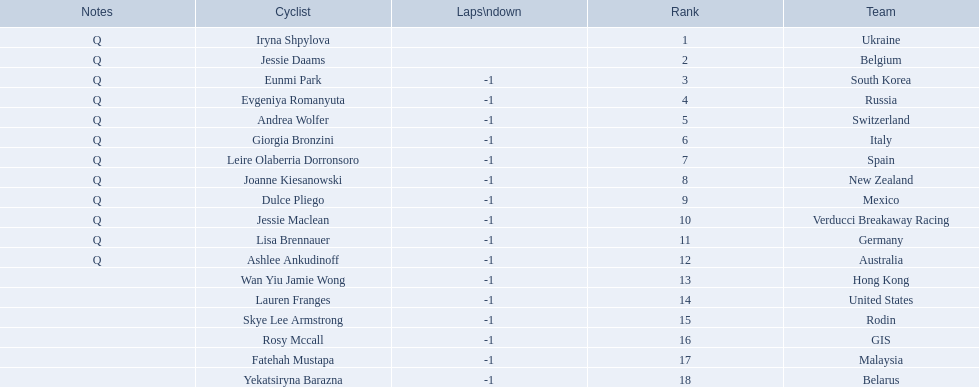What two cyclists come from teams with no laps down? Iryna Shpylova, Jessie Daams. 